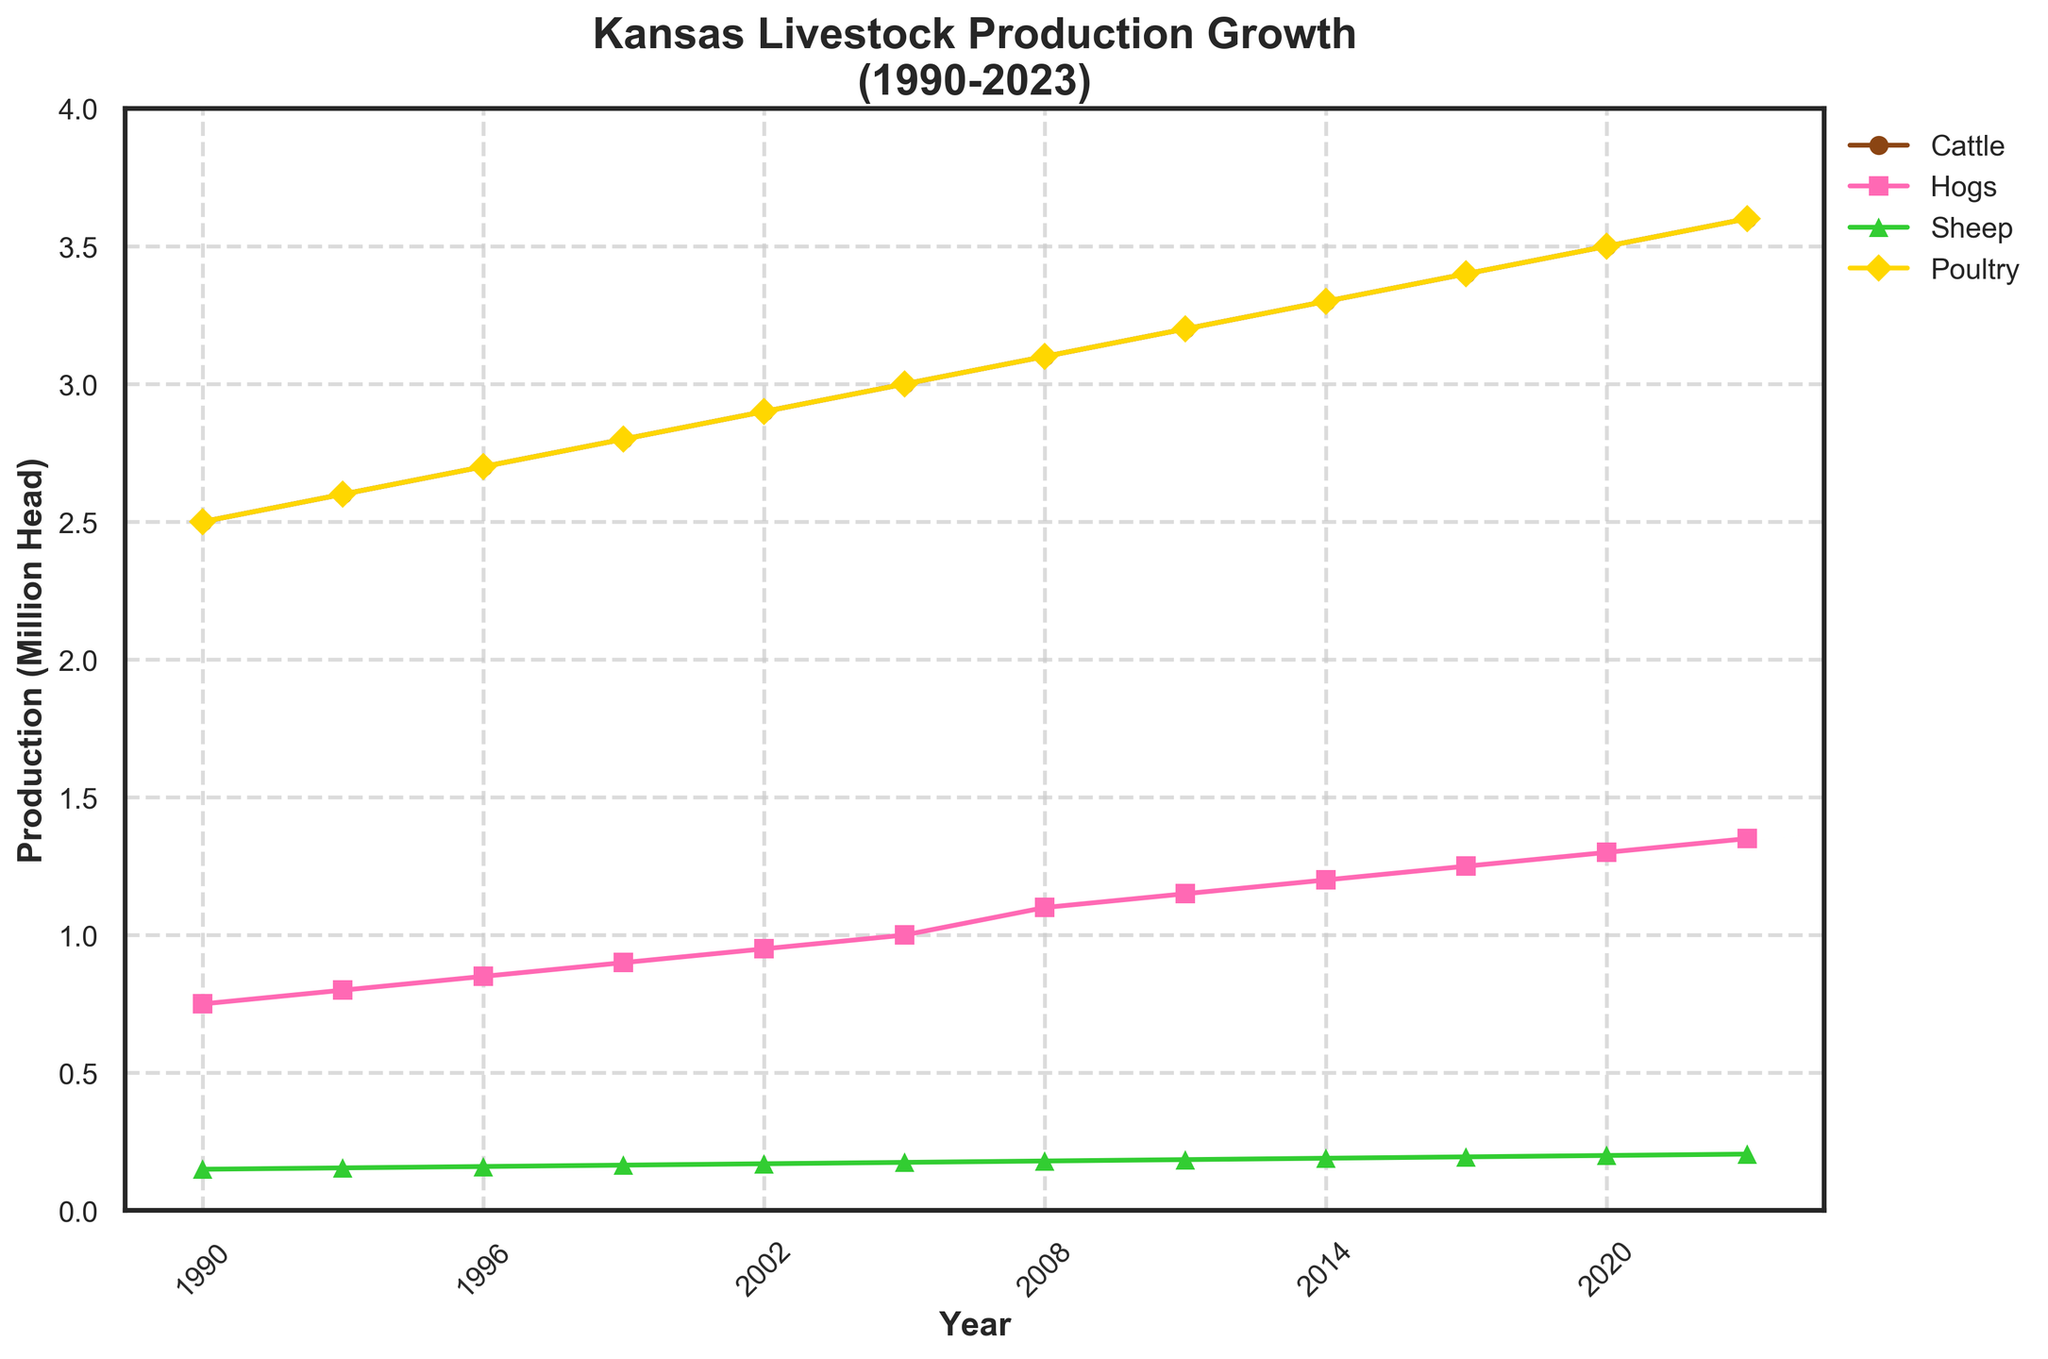How are the production trends for cattle and hogs different? Observing the plot, cattle production shows a steady, linear increase from 2.5 million head in 1990 to 3.6 million head in 2023. Hog production also increases steadily but at a different rate, starting from 0.75 million head in 1990 to 1.35 million head in 2023.
Answer: Cattle production increases faster and more consistently than hog production How many years show identical values for poultry and cattle production? Reviewing the plot, identical values for poultry and cattle production occur at 1990, 1993, 1996, 1999, 2002, 2005, 2008, 2011, 2014, 2017, 2020, and 2023. That sums to 12 years where the values are identical.
Answer: Twelve Which livestock category had the least growth over the past three decades? Checking the plot, sheep production had the least growth, starting from 0.15 million head in 1990 to 0.205 million head in 2023. This increase is the smallest compared to the other categories.
Answer: Sheep What is the total increase in hog production from 1990 to 2023? In 1990, hog production was 0.75 million head, and by 2023, it was 1.35 million head. Calculating the difference gives 1.35 - 0.75 = 0.6 million head.
Answer: 0.6 million head Which year did cattle production first reach 3 million head? Tracing the cattle production line on the plot, cattle production first reached 3 million head in 2005.
Answer: 2005 In which year did poultry and hog production both see a significant increase? Examining the plot, both poultry and hog production show a noticeable increase around 2008.
Answer: 2008 How much more cattle were produced in 2023 compared to 1990? Cattle production in 2023 was 3.6 million head, and in 1990, it was 2.5 million head. The difference is 3.6 - 2.5 = 1.1 million head.
Answer: 1.1 million head Which livestock category had the highest growth rate? Evaluating the plot, cattle production had the highest growth rate, increasing from 2.5 million in 1990 to 3.6 million in 2023, which shows a faster rate compared to the other categories.
Answer: Cattle In which year did sheep production see its highest recorded value according to the plot? Observing the plot, sheep production's highest recorded value is in 2023, reaching 0.205 million head.
Answer: 2023 